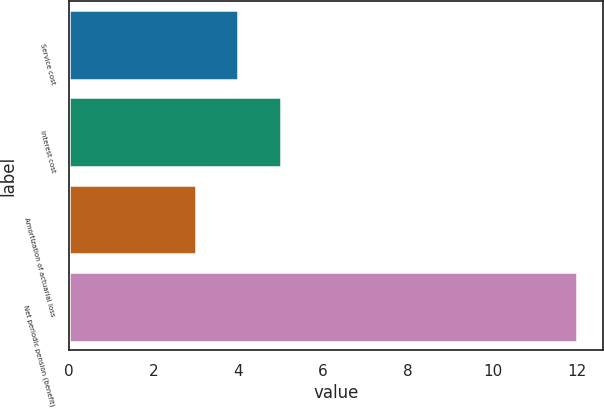<chart> <loc_0><loc_0><loc_500><loc_500><bar_chart><fcel>Service cost<fcel>Interest cost<fcel>Amortization of actuarial loss<fcel>Net periodic pension (benefit)<nl><fcel>4<fcel>5<fcel>3<fcel>12<nl></chart> 